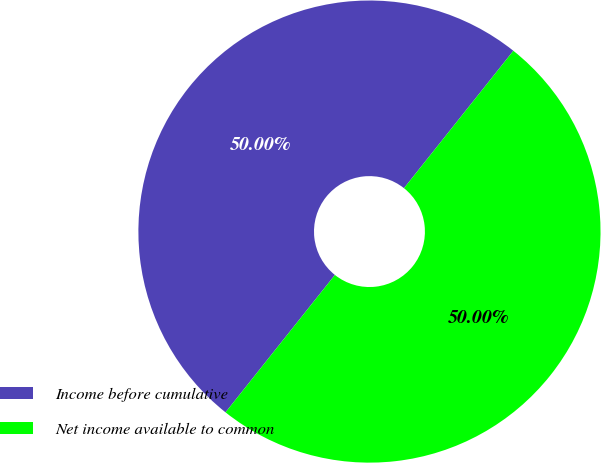<chart> <loc_0><loc_0><loc_500><loc_500><pie_chart><fcel>Income before cumulative<fcel>Net income available to common<nl><fcel>50.0%<fcel>50.0%<nl></chart> 